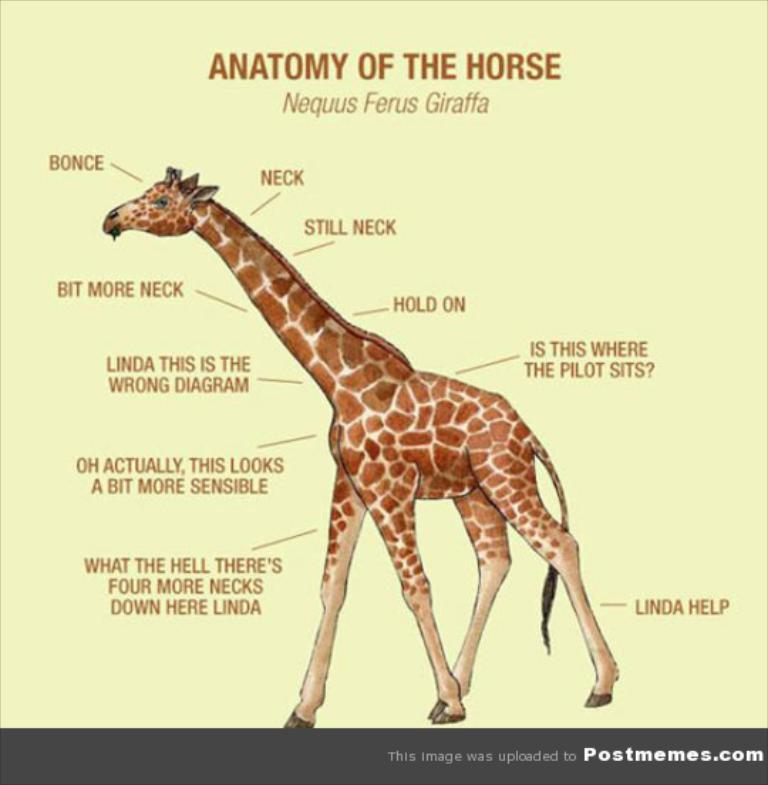What type of image is being described? The image is a poster. What animal can be seen in the poster? There is a giraffe standing in the poster. Are there any words or phrases on the poster? Yes, there is text on the poster. Can you tell me how many dogs are playing with a pipe in the poster? There are no dogs or pipes present in the poster; it features a giraffe and text. 